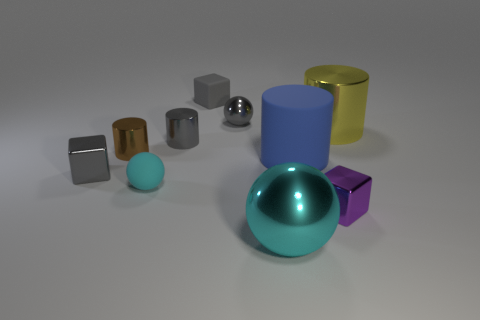Is there any other thing that is made of the same material as the blue object?
Provide a short and direct response. Yes. Is there a gray metal block that is in front of the big metal thing that is behind the large cylinder in front of the gray metal cylinder?
Offer a very short reply. Yes. Does the small gray shiny object behind the yellow object have the same shape as the brown metal object?
Offer a terse response. No. There is another ball that is the same material as the gray sphere; what is its color?
Your answer should be very brief. Cyan. What number of large yellow cubes have the same material as the large yellow object?
Keep it short and to the point. 0. What color is the ball that is right of the metallic ball that is behind the big shiny thing in front of the small gray metal block?
Keep it short and to the point. Cyan. Do the brown thing and the blue object have the same size?
Keep it short and to the point. No. How many things are either small shiny objects in front of the small gray metallic cylinder or cyan matte spheres?
Make the answer very short. 4. Is the shape of the blue object the same as the brown thing?
Provide a succinct answer. Yes. How many other things are there of the same size as the rubber cylinder?
Keep it short and to the point. 2. 